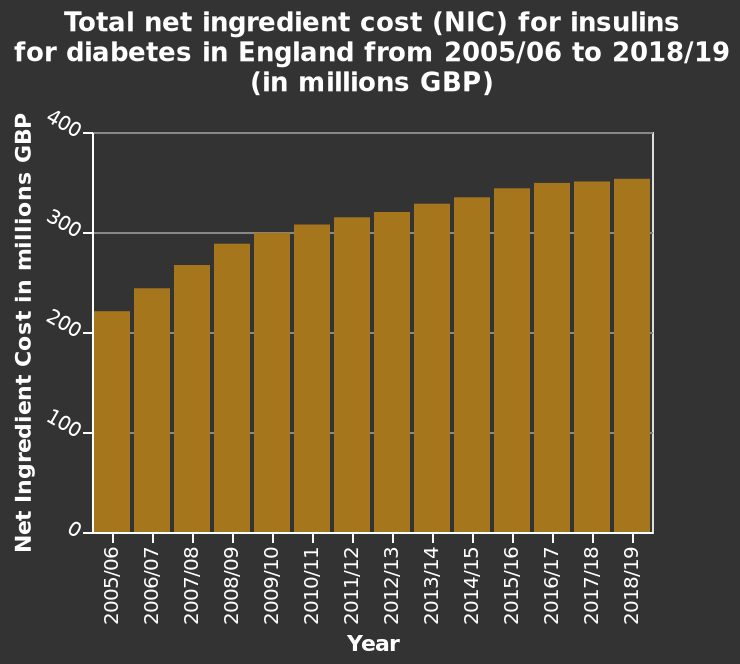<image>
During which period did the costs for insulin rise the sharpest?  The costs for insulin rose the sharpest between 2005/6 and 2009/10. What is the data represented on the x-axis of the bar plot? The x-axis of the bar plot represents the year. What is the data represented on the y-axis of the bar plot? The y-axis of the bar plot represents the net ingredient cost in millions of GBP. Offer a thorough analysis of the image. In thirteen years the  total net ingredients costs for insulin for diabetes has grown exponentially. Between 2005/6 and 2009/10 the costs rose the sharpest. From 2015/6 and 2018/19 the costs for insulin plateaued out. 